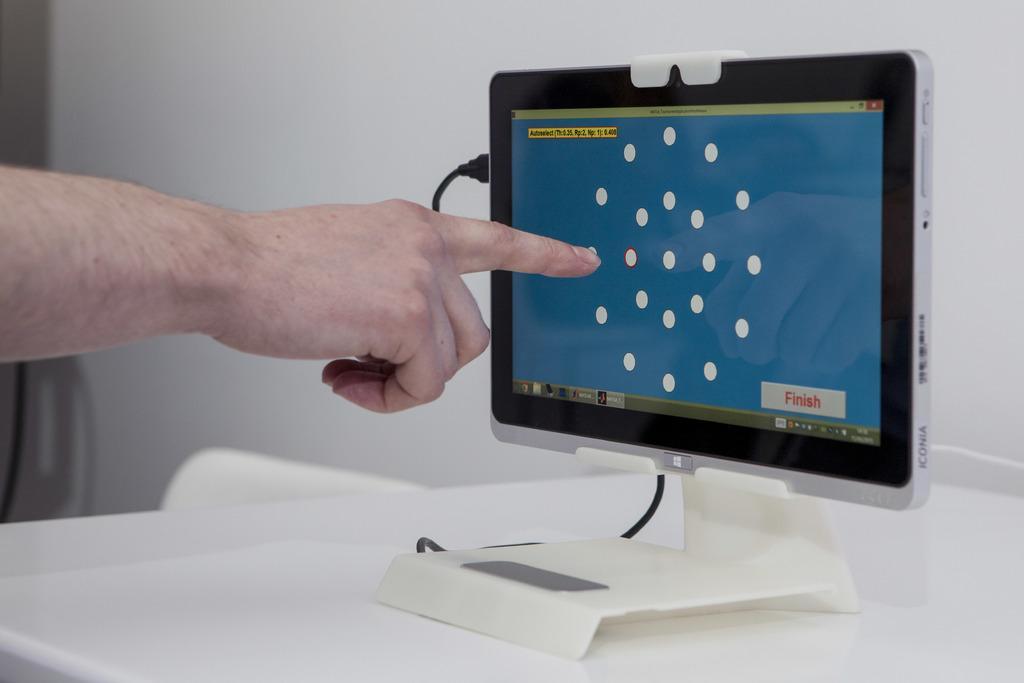Can you describe this image briefly? On this table there is a tab with cable. This person is pointing the screen. 